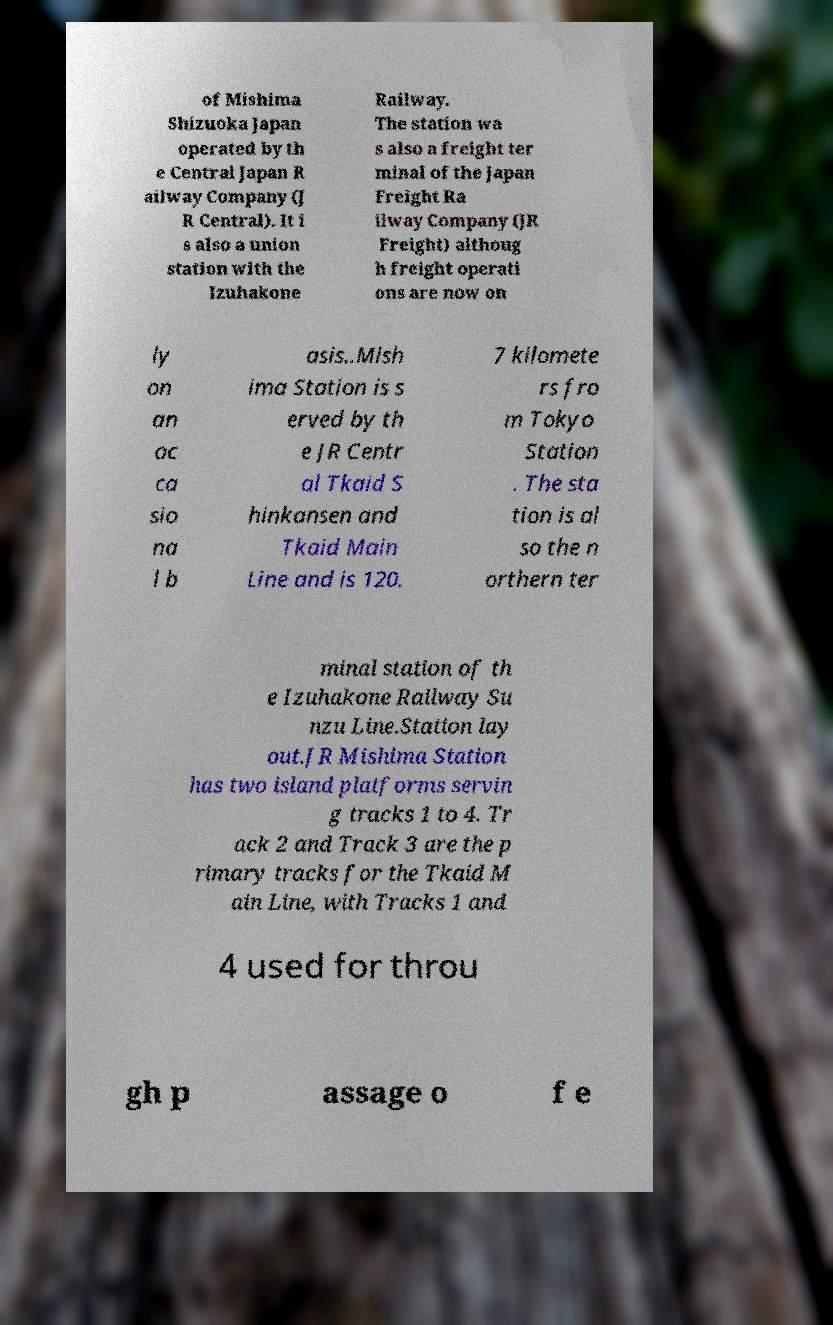Please identify and transcribe the text found in this image. of Mishima Shizuoka Japan operated by th e Central Japan R ailway Company (J R Central). It i s also a union station with the Izuhakone Railway. The station wa s also a freight ter minal of the Japan Freight Ra ilway Company (JR Freight) althoug h freight operati ons are now on ly on an oc ca sio na l b asis..Mish ima Station is s erved by th e JR Centr al Tkaid S hinkansen and Tkaid Main Line and is 120. 7 kilomete rs fro m Tokyo Station . The sta tion is al so the n orthern ter minal station of th e Izuhakone Railway Su nzu Line.Station lay out.JR Mishima Station has two island platforms servin g tracks 1 to 4. Tr ack 2 and Track 3 are the p rimary tracks for the Tkaid M ain Line, with Tracks 1 and 4 used for throu gh p assage o f e 